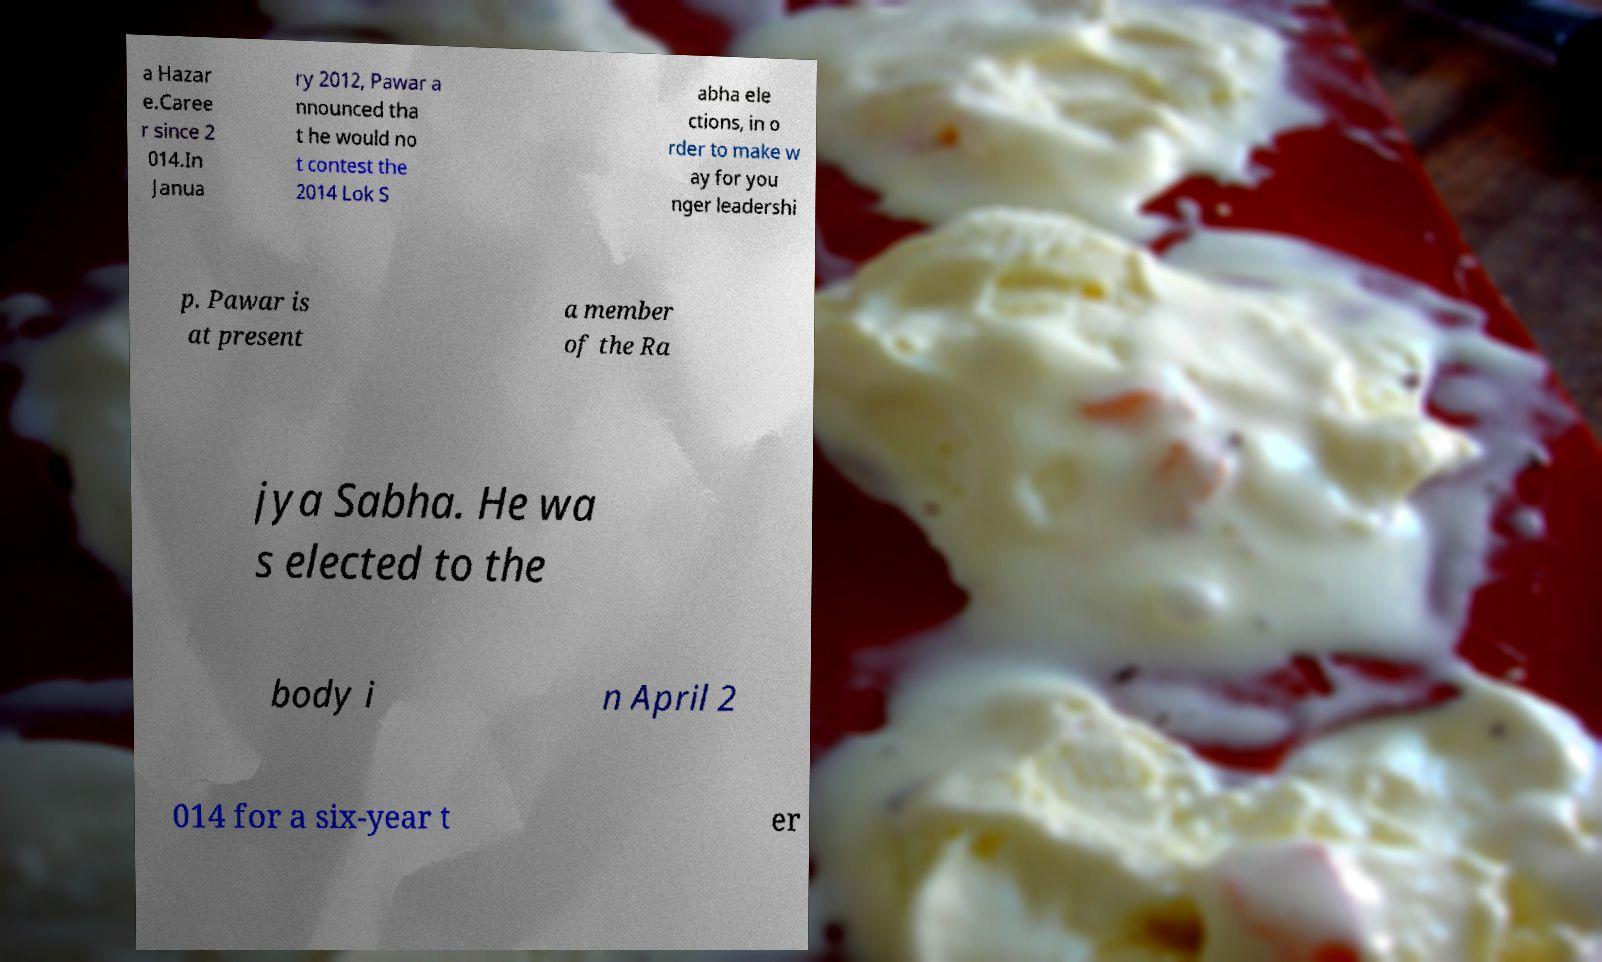Could you extract and type out the text from this image? a Hazar e.Caree r since 2 014.In Janua ry 2012, Pawar a nnounced tha t he would no t contest the 2014 Lok S abha ele ctions, in o rder to make w ay for you nger leadershi p. Pawar is at present a member of the Ra jya Sabha. He wa s elected to the body i n April 2 014 for a six-year t er 